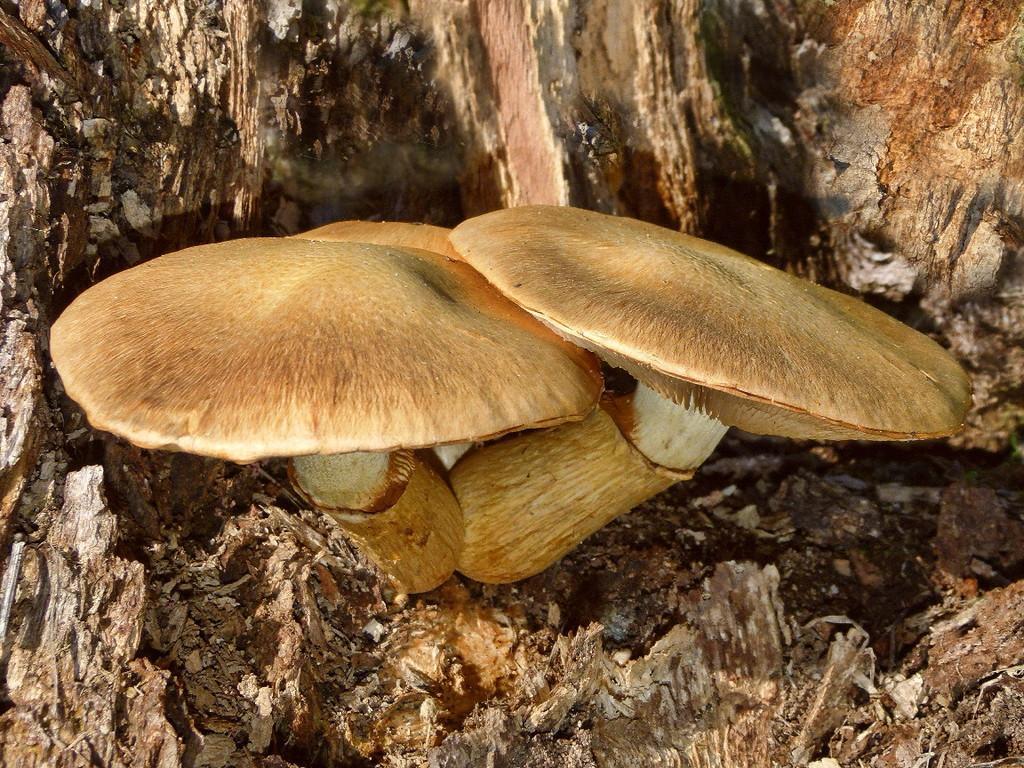Could you give a brief overview of what you see in this image? In this image we can see two mushrooms grown upon the tree. 